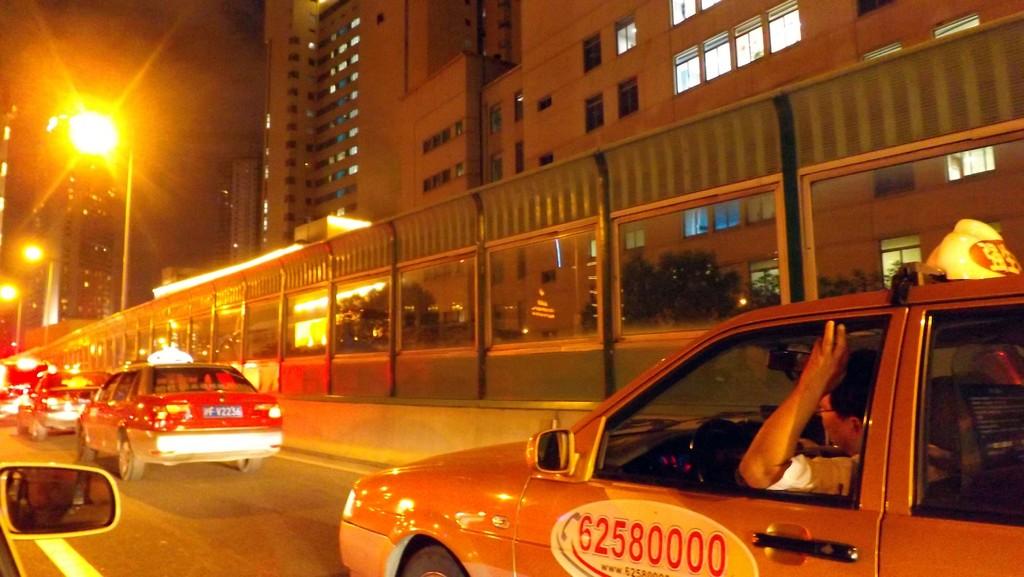What is the phone number for this taxi?
Your answer should be compact. 62580000. 